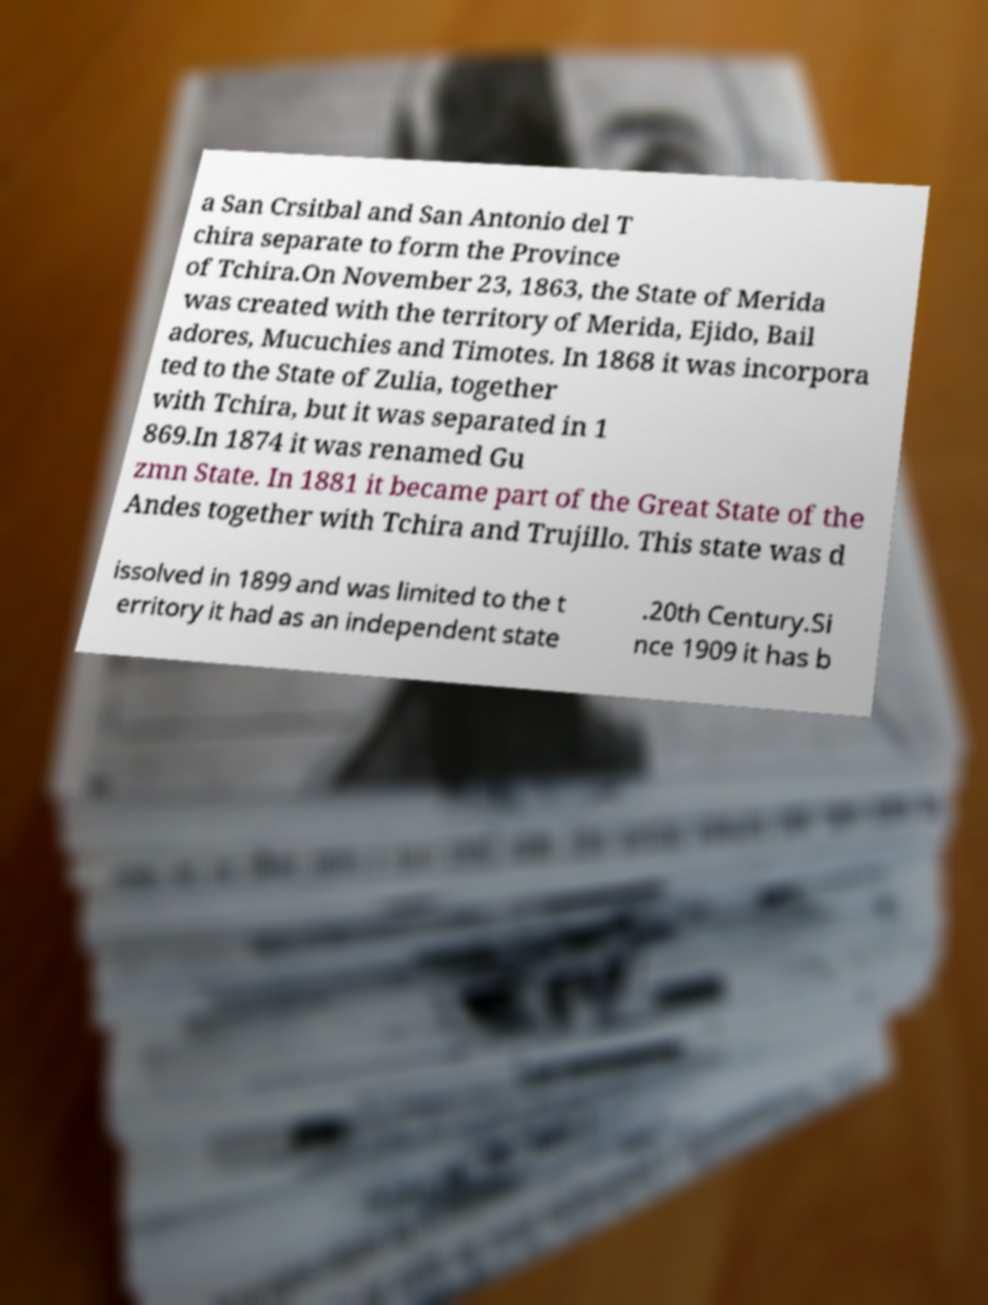There's text embedded in this image that I need extracted. Can you transcribe it verbatim? a San Crsitbal and San Antonio del T chira separate to form the Province of Tchira.On November 23, 1863, the State of Merida was created with the territory of Merida, Ejido, Bail adores, Mucuchies and Timotes. In 1868 it was incorpora ted to the State of Zulia, together with Tchira, but it was separated in 1 869.In 1874 it was renamed Gu zmn State. In 1881 it became part of the Great State of the Andes together with Tchira and Trujillo. This state was d issolved in 1899 and was limited to the t erritory it had as an independent state .20th Century.Si nce 1909 it has b 